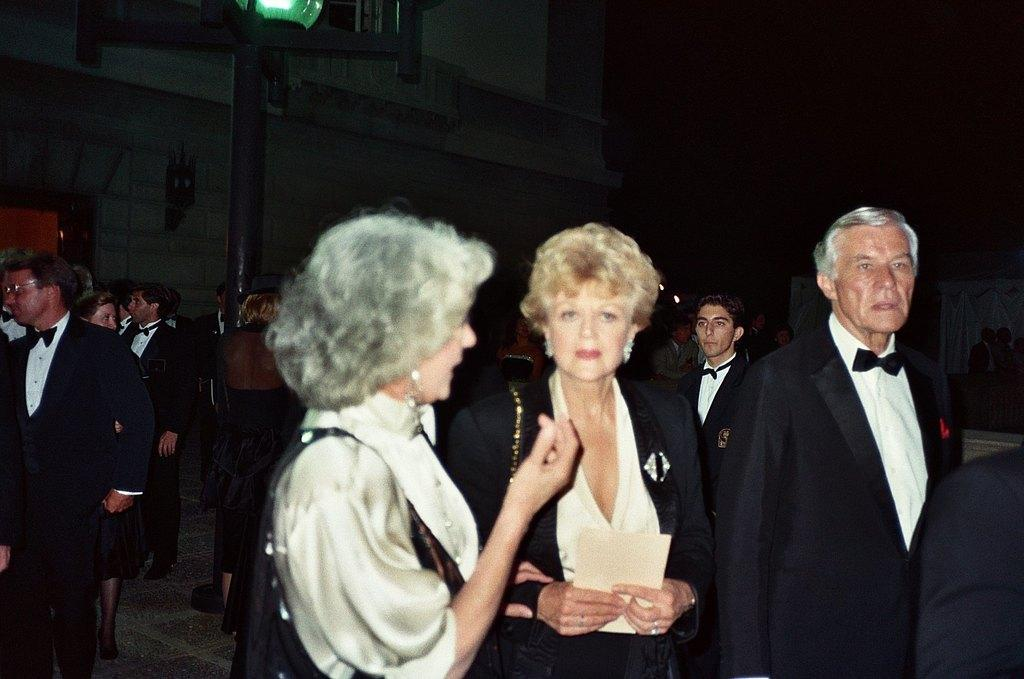How many people are in the image? There is a group of people in the image. What are the people in the image doing? The people are standing in one place. What can be seen in the background of the image? There is a building visible in the background of the image. What is the representative's wealth in the image? There is no representative present in the image, and therefore no wealth can be attributed to them. 